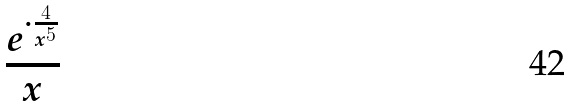<formula> <loc_0><loc_0><loc_500><loc_500>\frac { e ^ { \cdot \frac { 4 } { x ^ { 5 } } } } { x }</formula> 